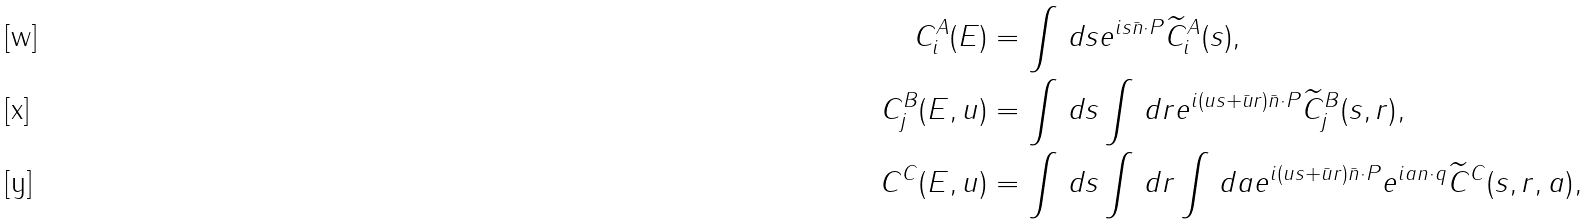<formula> <loc_0><loc_0><loc_500><loc_500>C _ { i } ^ { A } ( E ) & = \int \, d s e ^ { i s \bar { n } \cdot P } \widetilde { C } _ { i } ^ { A } ( s ) , \\ C _ { j } ^ { B } ( E , u ) & = \int \, d s \int \, d r e ^ { i ( u s + { \bar { u } } r ) { \bar { n } } \cdot P } \widetilde { C } _ { j } ^ { B } ( s , r ) , \\ C ^ { C } ( E , u ) & = \int \, d s \int \, d r \int \, d a e ^ { i ( u s + { \bar { u } } r ) { \bar { n } } \cdot P } e ^ { i a n \cdot q } \widetilde { C } ^ { C } ( s , r , a ) ,</formula> 